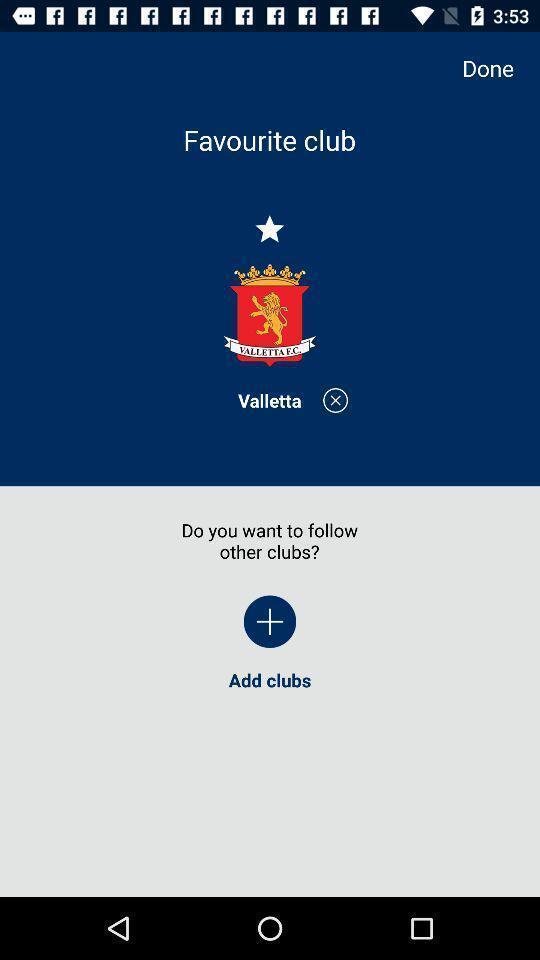Provide a description of this screenshot. Screen shows favorites club in sports application. 